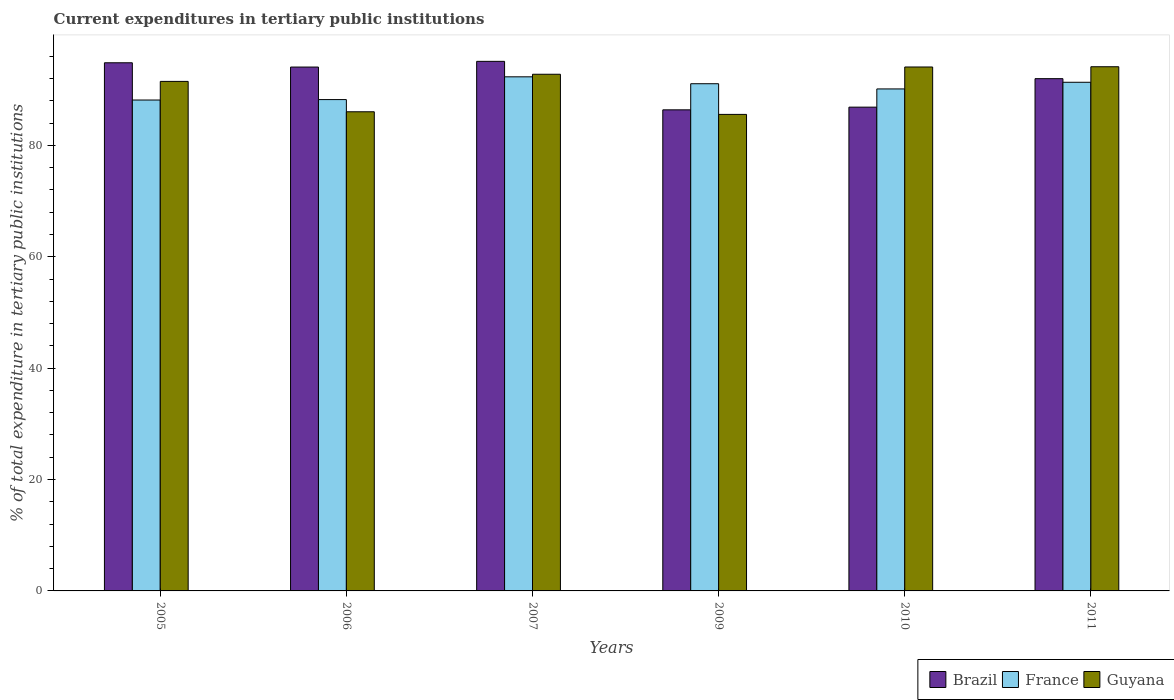Are the number of bars per tick equal to the number of legend labels?
Give a very brief answer. Yes. Are the number of bars on each tick of the X-axis equal?
Your answer should be very brief. Yes. How many bars are there on the 5th tick from the right?
Ensure brevity in your answer.  3. In how many cases, is the number of bars for a given year not equal to the number of legend labels?
Offer a terse response. 0. What is the current expenditures in tertiary public institutions in Brazil in 2011?
Offer a terse response. 91.99. Across all years, what is the maximum current expenditures in tertiary public institutions in Brazil?
Your answer should be very brief. 95.09. Across all years, what is the minimum current expenditures in tertiary public institutions in France?
Offer a very short reply. 88.15. In which year was the current expenditures in tertiary public institutions in Guyana maximum?
Provide a succinct answer. 2011. What is the total current expenditures in tertiary public institutions in France in the graph?
Your answer should be very brief. 541.25. What is the difference between the current expenditures in tertiary public institutions in France in 2007 and that in 2010?
Give a very brief answer. 2.17. What is the difference between the current expenditures in tertiary public institutions in Guyana in 2011 and the current expenditures in tertiary public institutions in France in 2005?
Ensure brevity in your answer.  5.98. What is the average current expenditures in tertiary public institutions in Brazil per year?
Provide a succinct answer. 91.54. In the year 2007, what is the difference between the current expenditures in tertiary public institutions in Guyana and current expenditures in tertiary public institutions in Brazil?
Offer a terse response. -2.32. In how many years, is the current expenditures in tertiary public institutions in Brazil greater than 56 %?
Provide a short and direct response. 6. What is the ratio of the current expenditures in tertiary public institutions in France in 2005 to that in 2011?
Keep it short and to the point. 0.97. Is the difference between the current expenditures in tertiary public institutions in Guyana in 2009 and 2011 greater than the difference between the current expenditures in tertiary public institutions in Brazil in 2009 and 2011?
Offer a very short reply. No. What is the difference between the highest and the second highest current expenditures in tertiary public institutions in Guyana?
Provide a succinct answer. 0.04. What is the difference between the highest and the lowest current expenditures in tertiary public institutions in France?
Your answer should be compact. 4.17. In how many years, is the current expenditures in tertiary public institutions in Brazil greater than the average current expenditures in tertiary public institutions in Brazil taken over all years?
Your answer should be compact. 4. What does the 3rd bar from the left in 2010 represents?
Ensure brevity in your answer.  Guyana. What does the 3rd bar from the right in 2010 represents?
Ensure brevity in your answer.  Brazil. How many years are there in the graph?
Provide a succinct answer. 6. Does the graph contain grids?
Give a very brief answer. No. Where does the legend appear in the graph?
Give a very brief answer. Bottom right. How are the legend labels stacked?
Ensure brevity in your answer.  Horizontal. What is the title of the graph?
Give a very brief answer. Current expenditures in tertiary public institutions. What is the label or title of the X-axis?
Provide a succinct answer. Years. What is the label or title of the Y-axis?
Offer a very short reply. % of total expenditure in tertiary public institutions. What is the % of total expenditure in tertiary public institutions of Brazil in 2005?
Your answer should be very brief. 94.84. What is the % of total expenditure in tertiary public institutions of France in 2005?
Your answer should be compact. 88.15. What is the % of total expenditure in tertiary public institutions of Guyana in 2005?
Provide a succinct answer. 91.49. What is the % of total expenditure in tertiary public institutions in Brazil in 2006?
Your answer should be compact. 94.07. What is the % of total expenditure in tertiary public institutions in France in 2006?
Your answer should be very brief. 88.23. What is the % of total expenditure in tertiary public institutions in Guyana in 2006?
Make the answer very short. 86.04. What is the % of total expenditure in tertiary public institutions of Brazil in 2007?
Your answer should be compact. 95.09. What is the % of total expenditure in tertiary public institutions in France in 2007?
Offer a very short reply. 92.32. What is the % of total expenditure in tertiary public institutions in Guyana in 2007?
Your response must be concise. 92.78. What is the % of total expenditure in tertiary public institutions in Brazil in 2009?
Offer a very short reply. 86.39. What is the % of total expenditure in tertiary public institutions in France in 2009?
Offer a terse response. 91.08. What is the % of total expenditure in tertiary public institutions of Guyana in 2009?
Offer a very short reply. 85.57. What is the % of total expenditure in tertiary public institutions in Brazil in 2010?
Keep it short and to the point. 86.87. What is the % of total expenditure in tertiary public institutions in France in 2010?
Offer a very short reply. 90.14. What is the % of total expenditure in tertiary public institutions of Guyana in 2010?
Your response must be concise. 94.08. What is the % of total expenditure in tertiary public institutions of Brazil in 2011?
Your answer should be compact. 91.99. What is the % of total expenditure in tertiary public institutions in France in 2011?
Make the answer very short. 91.34. What is the % of total expenditure in tertiary public institutions in Guyana in 2011?
Offer a terse response. 94.13. Across all years, what is the maximum % of total expenditure in tertiary public institutions of Brazil?
Ensure brevity in your answer.  95.09. Across all years, what is the maximum % of total expenditure in tertiary public institutions in France?
Make the answer very short. 92.32. Across all years, what is the maximum % of total expenditure in tertiary public institutions of Guyana?
Make the answer very short. 94.13. Across all years, what is the minimum % of total expenditure in tertiary public institutions of Brazil?
Give a very brief answer. 86.39. Across all years, what is the minimum % of total expenditure in tertiary public institutions in France?
Provide a short and direct response. 88.15. Across all years, what is the minimum % of total expenditure in tertiary public institutions of Guyana?
Offer a terse response. 85.57. What is the total % of total expenditure in tertiary public institutions of Brazil in the graph?
Provide a short and direct response. 549.25. What is the total % of total expenditure in tertiary public institutions in France in the graph?
Offer a very short reply. 541.25. What is the total % of total expenditure in tertiary public institutions of Guyana in the graph?
Your answer should be very brief. 544.09. What is the difference between the % of total expenditure in tertiary public institutions of Brazil in 2005 and that in 2006?
Provide a succinct answer. 0.77. What is the difference between the % of total expenditure in tertiary public institutions in France in 2005 and that in 2006?
Keep it short and to the point. -0.08. What is the difference between the % of total expenditure in tertiary public institutions in Guyana in 2005 and that in 2006?
Keep it short and to the point. 5.45. What is the difference between the % of total expenditure in tertiary public institutions of Brazil in 2005 and that in 2007?
Provide a short and direct response. -0.25. What is the difference between the % of total expenditure in tertiary public institutions of France in 2005 and that in 2007?
Give a very brief answer. -4.17. What is the difference between the % of total expenditure in tertiary public institutions of Guyana in 2005 and that in 2007?
Offer a terse response. -1.28. What is the difference between the % of total expenditure in tertiary public institutions of Brazil in 2005 and that in 2009?
Your response must be concise. 8.45. What is the difference between the % of total expenditure in tertiary public institutions of France in 2005 and that in 2009?
Provide a short and direct response. -2.93. What is the difference between the % of total expenditure in tertiary public institutions of Guyana in 2005 and that in 2009?
Give a very brief answer. 5.92. What is the difference between the % of total expenditure in tertiary public institutions in Brazil in 2005 and that in 2010?
Ensure brevity in your answer.  7.97. What is the difference between the % of total expenditure in tertiary public institutions in France in 2005 and that in 2010?
Provide a short and direct response. -1.99. What is the difference between the % of total expenditure in tertiary public institutions of Guyana in 2005 and that in 2010?
Offer a very short reply. -2.59. What is the difference between the % of total expenditure in tertiary public institutions of Brazil in 2005 and that in 2011?
Keep it short and to the point. 2.85. What is the difference between the % of total expenditure in tertiary public institutions of France in 2005 and that in 2011?
Provide a succinct answer. -3.19. What is the difference between the % of total expenditure in tertiary public institutions in Guyana in 2005 and that in 2011?
Your response must be concise. -2.63. What is the difference between the % of total expenditure in tertiary public institutions in Brazil in 2006 and that in 2007?
Your response must be concise. -1.02. What is the difference between the % of total expenditure in tertiary public institutions in France in 2006 and that in 2007?
Your answer should be very brief. -4.09. What is the difference between the % of total expenditure in tertiary public institutions of Guyana in 2006 and that in 2007?
Give a very brief answer. -6.73. What is the difference between the % of total expenditure in tertiary public institutions of Brazil in 2006 and that in 2009?
Give a very brief answer. 7.68. What is the difference between the % of total expenditure in tertiary public institutions of France in 2006 and that in 2009?
Make the answer very short. -2.85. What is the difference between the % of total expenditure in tertiary public institutions in Guyana in 2006 and that in 2009?
Make the answer very short. 0.47. What is the difference between the % of total expenditure in tertiary public institutions of Brazil in 2006 and that in 2010?
Keep it short and to the point. 7.2. What is the difference between the % of total expenditure in tertiary public institutions of France in 2006 and that in 2010?
Your answer should be very brief. -1.91. What is the difference between the % of total expenditure in tertiary public institutions of Guyana in 2006 and that in 2010?
Give a very brief answer. -8.04. What is the difference between the % of total expenditure in tertiary public institutions in Brazil in 2006 and that in 2011?
Give a very brief answer. 2.09. What is the difference between the % of total expenditure in tertiary public institutions of France in 2006 and that in 2011?
Provide a succinct answer. -3.11. What is the difference between the % of total expenditure in tertiary public institutions of Guyana in 2006 and that in 2011?
Your answer should be very brief. -8.09. What is the difference between the % of total expenditure in tertiary public institutions in Brazil in 2007 and that in 2009?
Make the answer very short. 8.71. What is the difference between the % of total expenditure in tertiary public institutions of France in 2007 and that in 2009?
Your answer should be very brief. 1.24. What is the difference between the % of total expenditure in tertiary public institutions of Guyana in 2007 and that in 2009?
Provide a succinct answer. 7.21. What is the difference between the % of total expenditure in tertiary public institutions of Brazil in 2007 and that in 2010?
Provide a short and direct response. 8.22. What is the difference between the % of total expenditure in tertiary public institutions of France in 2007 and that in 2010?
Offer a very short reply. 2.17. What is the difference between the % of total expenditure in tertiary public institutions in Guyana in 2007 and that in 2010?
Your response must be concise. -1.31. What is the difference between the % of total expenditure in tertiary public institutions in Brazil in 2007 and that in 2011?
Ensure brevity in your answer.  3.11. What is the difference between the % of total expenditure in tertiary public institutions in France in 2007 and that in 2011?
Provide a succinct answer. 0.98. What is the difference between the % of total expenditure in tertiary public institutions of Guyana in 2007 and that in 2011?
Provide a short and direct response. -1.35. What is the difference between the % of total expenditure in tertiary public institutions in Brazil in 2009 and that in 2010?
Provide a succinct answer. -0.48. What is the difference between the % of total expenditure in tertiary public institutions of France in 2009 and that in 2010?
Make the answer very short. 0.93. What is the difference between the % of total expenditure in tertiary public institutions in Guyana in 2009 and that in 2010?
Offer a very short reply. -8.51. What is the difference between the % of total expenditure in tertiary public institutions in Brazil in 2009 and that in 2011?
Offer a terse response. -5.6. What is the difference between the % of total expenditure in tertiary public institutions in France in 2009 and that in 2011?
Give a very brief answer. -0.26. What is the difference between the % of total expenditure in tertiary public institutions of Guyana in 2009 and that in 2011?
Your answer should be very brief. -8.56. What is the difference between the % of total expenditure in tertiary public institutions in Brazil in 2010 and that in 2011?
Provide a succinct answer. -5.11. What is the difference between the % of total expenditure in tertiary public institutions in France in 2010 and that in 2011?
Provide a succinct answer. -1.19. What is the difference between the % of total expenditure in tertiary public institutions in Guyana in 2010 and that in 2011?
Offer a terse response. -0.04. What is the difference between the % of total expenditure in tertiary public institutions of Brazil in 2005 and the % of total expenditure in tertiary public institutions of France in 2006?
Provide a short and direct response. 6.61. What is the difference between the % of total expenditure in tertiary public institutions of Brazil in 2005 and the % of total expenditure in tertiary public institutions of Guyana in 2006?
Offer a terse response. 8.8. What is the difference between the % of total expenditure in tertiary public institutions in France in 2005 and the % of total expenditure in tertiary public institutions in Guyana in 2006?
Keep it short and to the point. 2.11. What is the difference between the % of total expenditure in tertiary public institutions in Brazil in 2005 and the % of total expenditure in tertiary public institutions in France in 2007?
Offer a terse response. 2.52. What is the difference between the % of total expenditure in tertiary public institutions of Brazil in 2005 and the % of total expenditure in tertiary public institutions of Guyana in 2007?
Offer a very short reply. 2.06. What is the difference between the % of total expenditure in tertiary public institutions in France in 2005 and the % of total expenditure in tertiary public institutions in Guyana in 2007?
Your response must be concise. -4.62. What is the difference between the % of total expenditure in tertiary public institutions of Brazil in 2005 and the % of total expenditure in tertiary public institutions of France in 2009?
Your response must be concise. 3.76. What is the difference between the % of total expenditure in tertiary public institutions of Brazil in 2005 and the % of total expenditure in tertiary public institutions of Guyana in 2009?
Offer a terse response. 9.27. What is the difference between the % of total expenditure in tertiary public institutions in France in 2005 and the % of total expenditure in tertiary public institutions in Guyana in 2009?
Provide a succinct answer. 2.58. What is the difference between the % of total expenditure in tertiary public institutions of Brazil in 2005 and the % of total expenditure in tertiary public institutions of France in 2010?
Provide a short and direct response. 4.7. What is the difference between the % of total expenditure in tertiary public institutions in Brazil in 2005 and the % of total expenditure in tertiary public institutions in Guyana in 2010?
Your answer should be compact. 0.76. What is the difference between the % of total expenditure in tertiary public institutions in France in 2005 and the % of total expenditure in tertiary public institutions in Guyana in 2010?
Give a very brief answer. -5.93. What is the difference between the % of total expenditure in tertiary public institutions of Brazil in 2005 and the % of total expenditure in tertiary public institutions of France in 2011?
Ensure brevity in your answer.  3.5. What is the difference between the % of total expenditure in tertiary public institutions in Brazil in 2005 and the % of total expenditure in tertiary public institutions in Guyana in 2011?
Provide a short and direct response. 0.71. What is the difference between the % of total expenditure in tertiary public institutions in France in 2005 and the % of total expenditure in tertiary public institutions in Guyana in 2011?
Your response must be concise. -5.98. What is the difference between the % of total expenditure in tertiary public institutions in Brazil in 2006 and the % of total expenditure in tertiary public institutions in France in 2007?
Make the answer very short. 1.75. What is the difference between the % of total expenditure in tertiary public institutions of Brazil in 2006 and the % of total expenditure in tertiary public institutions of Guyana in 2007?
Your response must be concise. 1.3. What is the difference between the % of total expenditure in tertiary public institutions in France in 2006 and the % of total expenditure in tertiary public institutions in Guyana in 2007?
Ensure brevity in your answer.  -4.55. What is the difference between the % of total expenditure in tertiary public institutions in Brazil in 2006 and the % of total expenditure in tertiary public institutions in France in 2009?
Your response must be concise. 3. What is the difference between the % of total expenditure in tertiary public institutions of Brazil in 2006 and the % of total expenditure in tertiary public institutions of Guyana in 2009?
Your response must be concise. 8.5. What is the difference between the % of total expenditure in tertiary public institutions of France in 2006 and the % of total expenditure in tertiary public institutions of Guyana in 2009?
Provide a short and direct response. 2.66. What is the difference between the % of total expenditure in tertiary public institutions of Brazil in 2006 and the % of total expenditure in tertiary public institutions of France in 2010?
Your response must be concise. 3.93. What is the difference between the % of total expenditure in tertiary public institutions in Brazil in 2006 and the % of total expenditure in tertiary public institutions in Guyana in 2010?
Your answer should be compact. -0.01. What is the difference between the % of total expenditure in tertiary public institutions in France in 2006 and the % of total expenditure in tertiary public institutions in Guyana in 2010?
Keep it short and to the point. -5.85. What is the difference between the % of total expenditure in tertiary public institutions of Brazil in 2006 and the % of total expenditure in tertiary public institutions of France in 2011?
Offer a terse response. 2.73. What is the difference between the % of total expenditure in tertiary public institutions of Brazil in 2006 and the % of total expenditure in tertiary public institutions of Guyana in 2011?
Your response must be concise. -0.05. What is the difference between the % of total expenditure in tertiary public institutions in France in 2006 and the % of total expenditure in tertiary public institutions in Guyana in 2011?
Offer a terse response. -5.9. What is the difference between the % of total expenditure in tertiary public institutions of Brazil in 2007 and the % of total expenditure in tertiary public institutions of France in 2009?
Your response must be concise. 4.02. What is the difference between the % of total expenditure in tertiary public institutions in Brazil in 2007 and the % of total expenditure in tertiary public institutions in Guyana in 2009?
Offer a very short reply. 9.52. What is the difference between the % of total expenditure in tertiary public institutions in France in 2007 and the % of total expenditure in tertiary public institutions in Guyana in 2009?
Offer a very short reply. 6.75. What is the difference between the % of total expenditure in tertiary public institutions of Brazil in 2007 and the % of total expenditure in tertiary public institutions of France in 2010?
Offer a terse response. 4.95. What is the difference between the % of total expenditure in tertiary public institutions in Brazil in 2007 and the % of total expenditure in tertiary public institutions in Guyana in 2010?
Give a very brief answer. 1.01. What is the difference between the % of total expenditure in tertiary public institutions in France in 2007 and the % of total expenditure in tertiary public institutions in Guyana in 2010?
Your response must be concise. -1.76. What is the difference between the % of total expenditure in tertiary public institutions of Brazil in 2007 and the % of total expenditure in tertiary public institutions of France in 2011?
Offer a very short reply. 3.76. What is the difference between the % of total expenditure in tertiary public institutions in Brazil in 2007 and the % of total expenditure in tertiary public institutions in Guyana in 2011?
Give a very brief answer. 0.97. What is the difference between the % of total expenditure in tertiary public institutions of France in 2007 and the % of total expenditure in tertiary public institutions of Guyana in 2011?
Make the answer very short. -1.81. What is the difference between the % of total expenditure in tertiary public institutions in Brazil in 2009 and the % of total expenditure in tertiary public institutions in France in 2010?
Keep it short and to the point. -3.76. What is the difference between the % of total expenditure in tertiary public institutions in Brazil in 2009 and the % of total expenditure in tertiary public institutions in Guyana in 2010?
Your answer should be compact. -7.69. What is the difference between the % of total expenditure in tertiary public institutions of France in 2009 and the % of total expenditure in tertiary public institutions of Guyana in 2010?
Provide a succinct answer. -3.01. What is the difference between the % of total expenditure in tertiary public institutions of Brazil in 2009 and the % of total expenditure in tertiary public institutions of France in 2011?
Offer a terse response. -4.95. What is the difference between the % of total expenditure in tertiary public institutions of Brazil in 2009 and the % of total expenditure in tertiary public institutions of Guyana in 2011?
Offer a very short reply. -7.74. What is the difference between the % of total expenditure in tertiary public institutions of France in 2009 and the % of total expenditure in tertiary public institutions of Guyana in 2011?
Give a very brief answer. -3.05. What is the difference between the % of total expenditure in tertiary public institutions in Brazil in 2010 and the % of total expenditure in tertiary public institutions in France in 2011?
Keep it short and to the point. -4.47. What is the difference between the % of total expenditure in tertiary public institutions of Brazil in 2010 and the % of total expenditure in tertiary public institutions of Guyana in 2011?
Offer a terse response. -7.26. What is the difference between the % of total expenditure in tertiary public institutions in France in 2010 and the % of total expenditure in tertiary public institutions in Guyana in 2011?
Offer a terse response. -3.98. What is the average % of total expenditure in tertiary public institutions in Brazil per year?
Make the answer very short. 91.54. What is the average % of total expenditure in tertiary public institutions of France per year?
Offer a very short reply. 90.21. What is the average % of total expenditure in tertiary public institutions in Guyana per year?
Give a very brief answer. 90.68. In the year 2005, what is the difference between the % of total expenditure in tertiary public institutions of Brazil and % of total expenditure in tertiary public institutions of France?
Offer a very short reply. 6.69. In the year 2005, what is the difference between the % of total expenditure in tertiary public institutions in Brazil and % of total expenditure in tertiary public institutions in Guyana?
Your answer should be compact. 3.35. In the year 2005, what is the difference between the % of total expenditure in tertiary public institutions in France and % of total expenditure in tertiary public institutions in Guyana?
Provide a short and direct response. -3.34. In the year 2006, what is the difference between the % of total expenditure in tertiary public institutions in Brazil and % of total expenditure in tertiary public institutions in France?
Your answer should be compact. 5.84. In the year 2006, what is the difference between the % of total expenditure in tertiary public institutions in Brazil and % of total expenditure in tertiary public institutions in Guyana?
Offer a very short reply. 8.03. In the year 2006, what is the difference between the % of total expenditure in tertiary public institutions of France and % of total expenditure in tertiary public institutions of Guyana?
Your answer should be compact. 2.19. In the year 2007, what is the difference between the % of total expenditure in tertiary public institutions of Brazil and % of total expenditure in tertiary public institutions of France?
Offer a terse response. 2.78. In the year 2007, what is the difference between the % of total expenditure in tertiary public institutions in Brazil and % of total expenditure in tertiary public institutions in Guyana?
Provide a succinct answer. 2.32. In the year 2007, what is the difference between the % of total expenditure in tertiary public institutions in France and % of total expenditure in tertiary public institutions in Guyana?
Your answer should be very brief. -0.46. In the year 2009, what is the difference between the % of total expenditure in tertiary public institutions of Brazil and % of total expenditure in tertiary public institutions of France?
Keep it short and to the point. -4.69. In the year 2009, what is the difference between the % of total expenditure in tertiary public institutions of Brazil and % of total expenditure in tertiary public institutions of Guyana?
Your answer should be very brief. 0.82. In the year 2009, what is the difference between the % of total expenditure in tertiary public institutions in France and % of total expenditure in tertiary public institutions in Guyana?
Your answer should be very brief. 5.51. In the year 2010, what is the difference between the % of total expenditure in tertiary public institutions in Brazil and % of total expenditure in tertiary public institutions in France?
Provide a succinct answer. -3.27. In the year 2010, what is the difference between the % of total expenditure in tertiary public institutions in Brazil and % of total expenditure in tertiary public institutions in Guyana?
Offer a very short reply. -7.21. In the year 2010, what is the difference between the % of total expenditure in tertiary public institutions in France and % of total expenditure in tertiary public institutions in Guyana?
Make the answer very short. -3.94. In the year 2011, what is the difference between the % of total expenditure in tertiary public institutions in Brazil and % of total expenditure in tertiary public institutions in France?
Keep it short and to the point. 0.65. In the year 2011, what is the difference between the % of total expenditure in tertiary public institutions in Brazil and % of total expenditure in tertiary public institutions in Guyana?
Provide a succinct answer. -2.14. In the year 2011, what is the difference between the % of total expenditure in tertiary public institutions in France and % of total expenditure in tertiary public institutions in Guyana?
Ensure brevity in your answer.  -2.79. What is the ratio of the % of total expenditure in tertiary public institutions in Brazil in 2005 to that in 2006?
Ensure brevity in your answer.  1.01. What is the ratio of the % of total expenditure in tertiary public institutions of France in 2005 to that in 2006?
Give a very brief answer. 1. What is the ratio of the % of total expenditure in tertiary public institutions in Guyana in 2005 to that in 2006?
Your answer should be compact. 1.06. What is the ratio of the % of total expenditure in tertiary public institutions of Brazil in 2005 to that in 2007?
Offer a terse response. 1. What is the ratio of the % of total expenditure in tertiary public institutions in France in 2005 to that in 2007?
Your answer should be very brief. 0.95. What is the ratio of the % of total expenditure in tertiary public institutions of Guyana in 2005 to that in 2007?
Offer a terse response. 0.99. What is the ratio of the % of total expenditure in tertiary public institutions in Brazil in 2005 to that in 2009?
Offer a terse response. 1.1. What is the ratio of the % of total expenditure in tertiary public institutions of France in 2005 to that in 2009?
Ensure brevity in your answer.  0.97. What is the ratio of the % of total expenditure in tertiary public institutions in Guyana in 2005 to that in 2009?
Offer a very short reply. 1.07. What is the ratio of the % of total expenditure in tertiary public institutions of Brazil in 2005 to that in 2010?
Ensure brevity in your answer.  1.09. What is the ratio of the % of total expenditure in tertiary public institutions of France in 2005 to that in 2010?
Your answer should be very brief. 0.98. What is the ratio of the % of total expenditure in tertiary public institutions in Guyana in 2005 to that in 2010?
Offer a terse response. 0.97. What is the ratio of the % of total expenditure in tertiary public institutions of Brazil in 2005 to that in 2011?
Offer a terse response. 1.03. What is the ratio of the % of total expenditure in tertiary public institutions in France in 2005 to that in 2011?
Keep it short and to the point. 0.97. What is the ratio of the % of total expenditure in tertiary public institutions in Brazil in 2006 to that in 2007?
Ensure brevity in your answer.  0.99. What is the ratio of the % of total expenditure in tertiary public institutions of France in 2006 to that in 2007?
Make the answer very short. 0.96. What is the ratio of the % of total expenditure in tertiary public institutions of Guyana in 2006 to that in 2007?
Your answer should be very brief. 0.93. What is the ratio of the % of total expenditure in tertiary public institutions in Brazil in 2006 to that in 2009?
Ensure brevity in your answer.  1.09. What is the ratio of the % of total expenditure in tertiary public institutions in France in 2006 to that in 2009?
Ensure brevity in your answer.  0.97. What is the ratio of the % of total expenditure in tertiary public institutions of Brazil in 2006 to that in 2010?
Your answer should be compact. 1.08. What is the ratio of the % of total expenditure in tertiary public institutions of France in 2006 to that in 2010?
Your answer should be very brief. 0.98. What is the ratio of the % of total expenditure in tertiary public institutions of Guyana in 2006 to that in 2010?
Keep it short and to the point. 0.91. What is the ratio of the % of total expenditure in tertiary public institutions in Brazil in 2006 to that in 2011?
Give a very brief answer. 1.02. What is the ratio of the % of total expenditure in tertiary public institutions in France in 2006 to that in 2011?
Provide a short and direct response. 0.97. What is the ratio of the % of total expenditure in tertiary public institutions in Guyana in 2006 to that in 2011?
Your response must be concise. 0.91. What is the ratio of the % of total expenditure in tertiary public institutions in Brazil in 2007 to that in 2009?
Your answer should be very brief. 1.1. What is the ratio of the % of total expenditure in tertiary public institutions in France in 2007 to that in 2009?
Provide a short and direct response. 1.01. What is the ratio of the % of total expenditure in tertiary public institutions in Guyana in 2007 to that in 2009?
Make the answer very short. 1.08. What is the ratio of the % of total expenditure in tertiary public institutions in Brazil in 2007 to that in 2010?
Provide a short and direct response. 1.09. What is the ratio of the % of total expenditure in tertiary public institutions in France in 2007 to that in 2010?
Your response must be concise. 1.02. What is the ratio of the % of total expenditure in tertiary public institutions of Guyana in 2007 to that in 2010?
Make the answer very short. 0.99. What is the ratio of the % of total expenditure in tertiary public institutions of Brazil in 2007 to that in 2011?
Your answer should be compact. 1.03. What is the ratio of the % of total expenditure in tertiary public institutions of France in 2007 to that in 2011?
Provide a succinct answer. 1.01. What is the ratio of the % of total expenditure in tertiary public institutions in Guyana in 2007 to that in 2011?
Offer a very short reply. 0.99. What is the ratio of the % of total expenditure in tertiary public institutions in Brazil in 2009 to that in 2010?
Your response must be concise. 0.99. What is the ratio of the % of total expenditure in tertiary public institutions in France in 2009 to that in 2010?
Offer a very short reply. 1.01. What is the ratio of the % of total expenditure in tertiary public institutions of Guyana in 2009 to that in 2010?
Offer a very short reply. 0.91. What is the ratio of the % of total expenditure in tertiary public institutions of Brazil in 2009 to that in 2011?
Your response must be concise. 0.94. What is the ratio of the % of total expenditure in tertiary public institutions in France in 2009 to that in 2011?
Provide a short and direct response. 1. What is the ratio of the % of total expenditure in tertiary public institutions in Brazil in 2010 to that in 2011?
Make the answer very short. 0.94. What is the ratio of the % of total expenditure in tertiary public institutions of France in 2010 to that in 2011?
Offer a terse response. 0.99. What is the difference between the highest and the second highest % of total expenditure in tertiary public institutions in Brazil?
Give a very brief answer. 0.25. What is the difference between the highest and the second highest % of total expenditure in tertiary public institutions in France?
Make the answer very short. 0.98. What is the difference between the highest and the second highest % of total expenditure in tertiary public institutions of Guyana?
Your response must be concise. 0.04. What is the difference between the highest and the lowest % of total expenditure in tertiary public institutions of Brazil?
Your response must be concise. 8.71. What is the difference between the highest and the lowest % of total expenditure in tertiary public institutions in France?
Keep it short and to the point. 4.17. What is the difference between the highest and the lowest % of total expenditure in tertiary public institutions in Guyana?
Offer a very short reply. 8.56. 